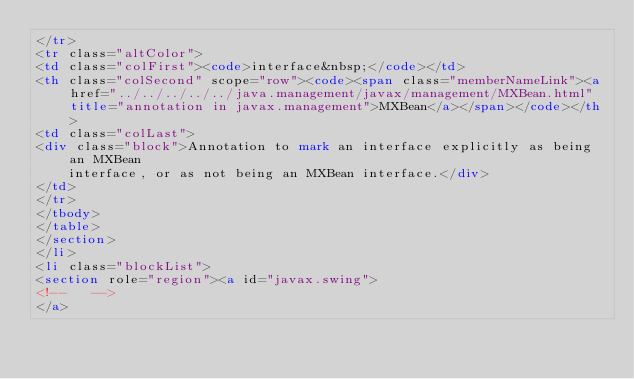Convert code to text. <code><loc_0><loc_0><loc_500><loc_500><_HTML_></tr>
<tr class="altColor">
<td class="colFirst"><code>interface&nbsp;</code></td>
<th class="colSecond" scope="row"><code><span class="memberNameLink"><a href="../../../../../java.management/javax/management/MXBean.html" title="annotation in javax.management">MXBean</a></span></code></th>
<td class="colLast">
<div class="block">Annotation to mark an interface explicitly as being an MXBean
    interface, or as not being an MXBean interface.</div>
</td>
</tr>
</tbody>
</table>
</section>
</li>
<li class="blockList">
<section role="region"><a id="javax.swing">
<!--   -->
</a></code> 